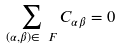Convert formula to latex. <formula><loc_0><loc_0><loc_500><loc_500>\sum _ { ( \alpha , \beta ) \in \ F } C _ { \alpha \beta } = 0</formula> 